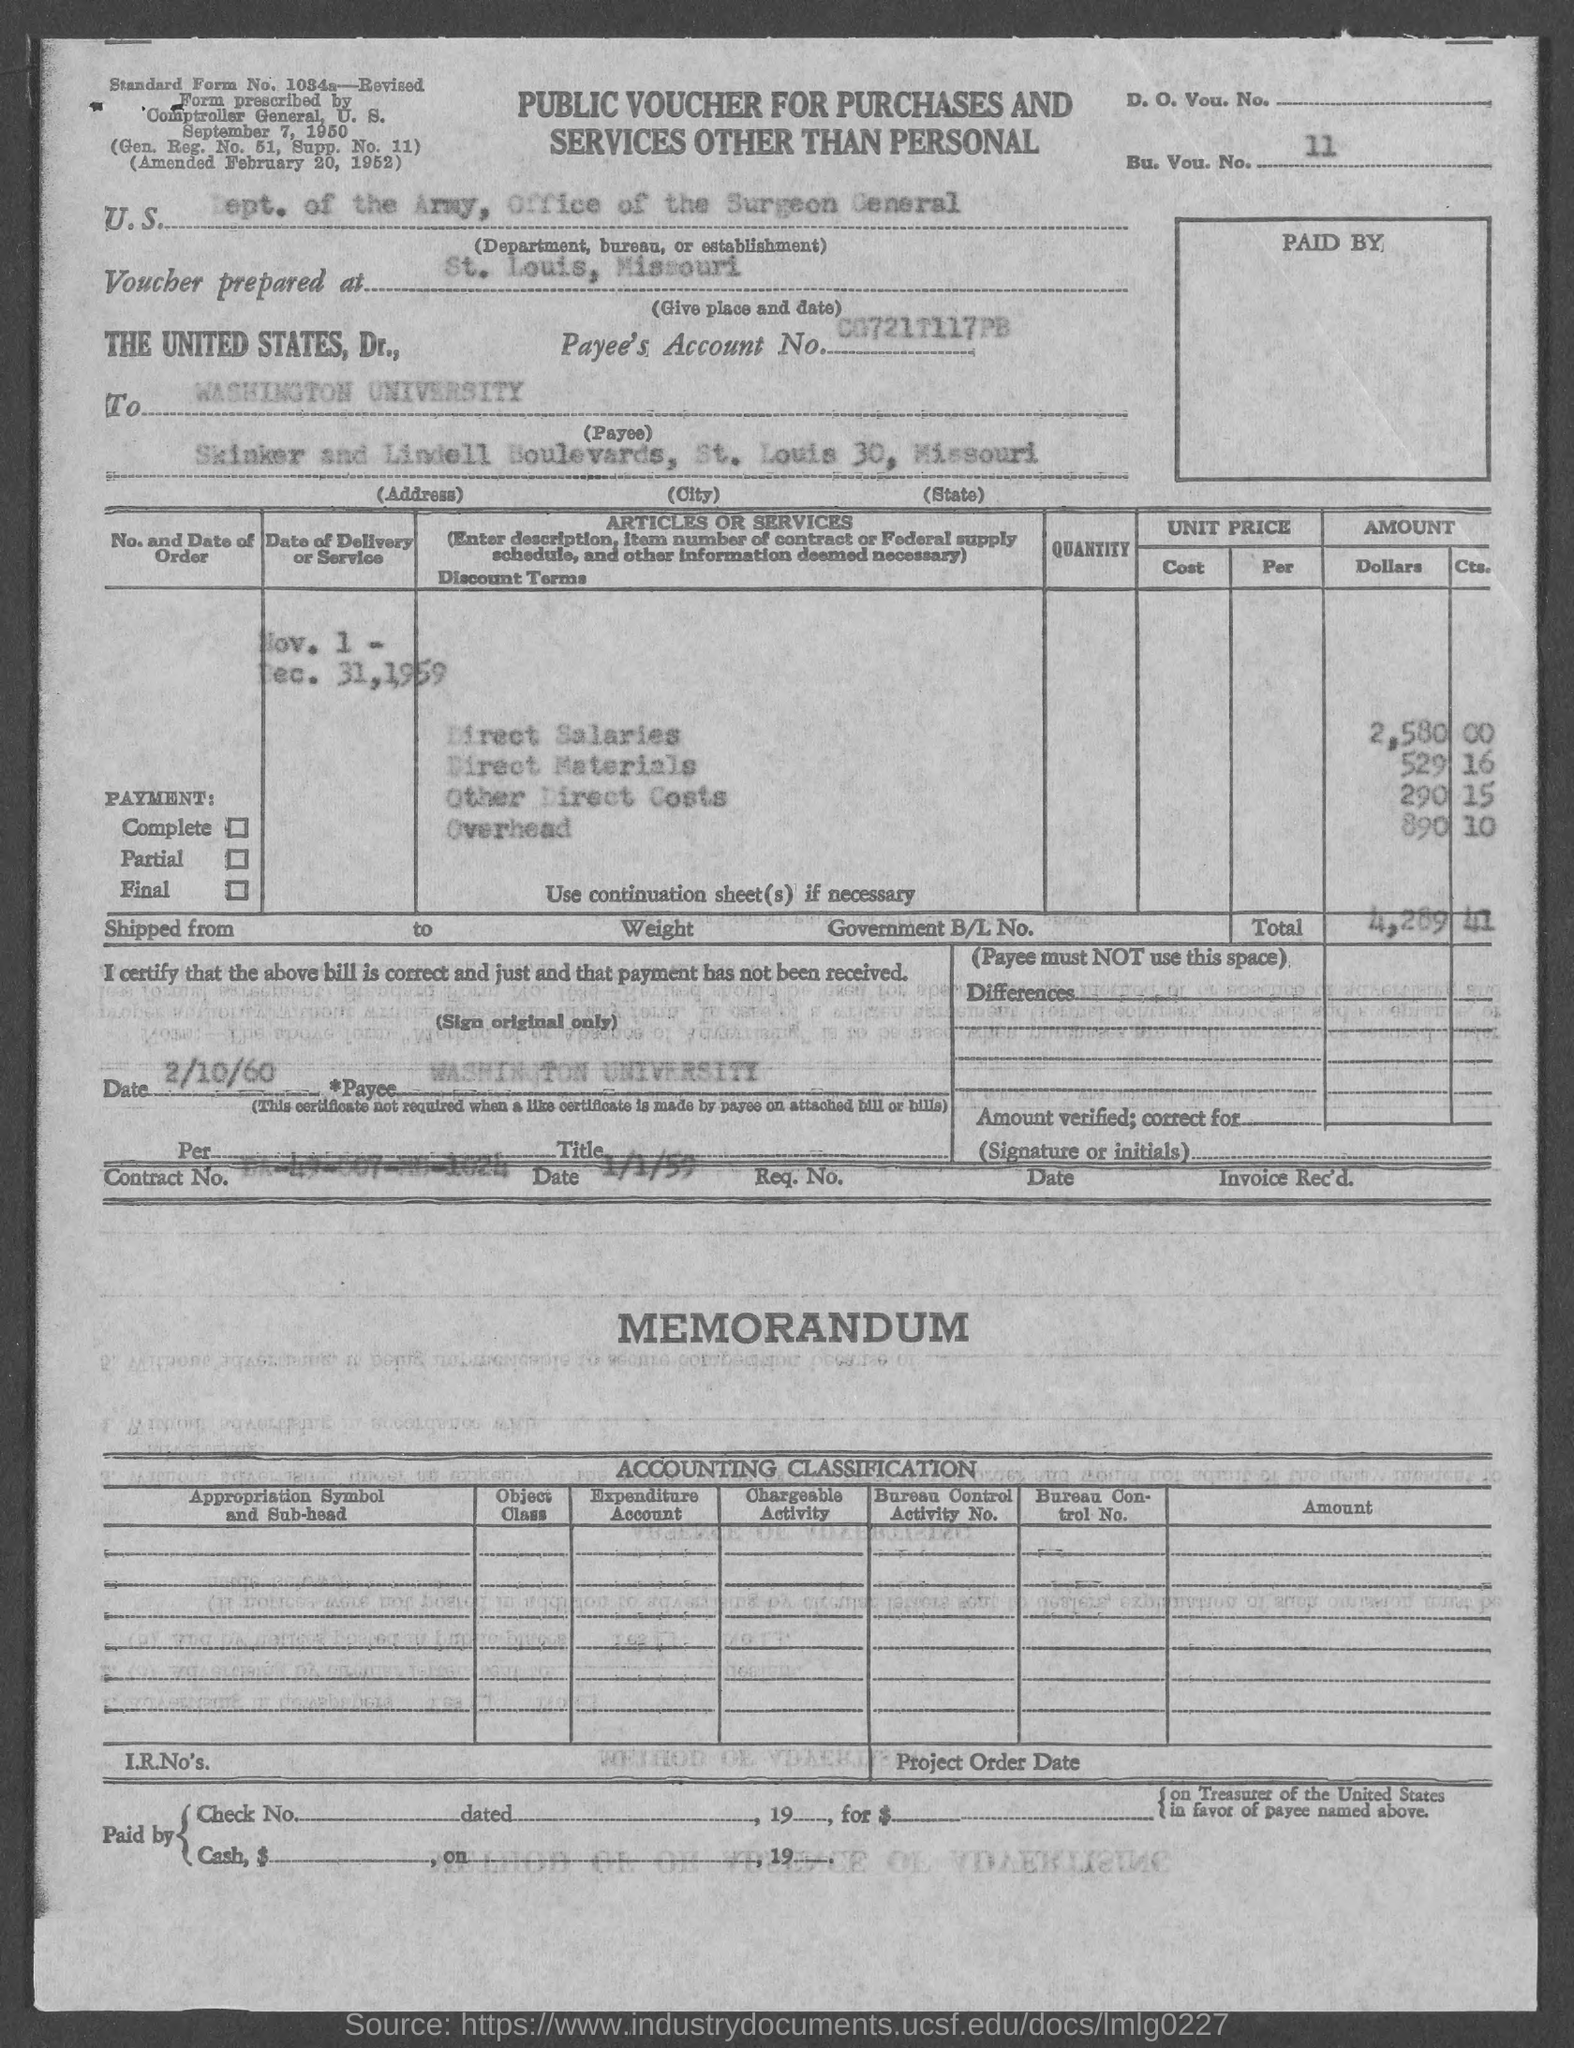What type of voucher is this?
Keep it short and to the point. Public Voucher for Purchases and Services Other Than Personal. What is the BU. VOU. NO. mentioned in the voucher?
Offer a terse response. 11. What is the U.S. Department, Bureau, or Establishment given in the voucher?
Your answer should be compact. Dept. of the Army, Office of the Surgeon General. Where is the voucher prepared at?
Provide a short and direct response. St. Louis, Missouri. Who is payee?
Provide a short and direct response. WASHINGTON UNIVERSITY. What is the direct salaries cost mentioned in the voucher?
Make the answer very short. 2,580.00. What is the Direct materials cost given in the voucher?
Make the answer very short. 529.16. What is the overhead cost given in the voucher?
Your answer should be very brief. 890 10. What is the total voucher amount mentioned in the document?
Offer a very short reply. $4,289.41. What is the Payee name given in the voucher?
Provide a succinct answer. WASHINGTON UNIVERSITY. 